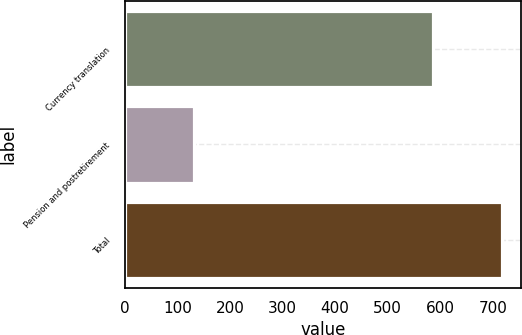Convert chart. <chart><loc_0><loc_0><loc_500><loc_500><bar_chart><fcel>Currency translation<fcel>Pension and postretirement<fcel>Total<nl><fcel>587<fcel>131<fcel>718<nl></chart> 